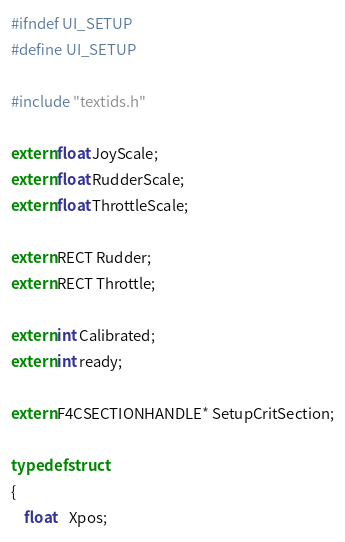Convert code to text. <code><loc_0><loc_0><loc_500><loc_500><_C_>#ifndef UI_SETUP
#define UI_SETUP

#include "textids.h"

extern float JoyScale;
extern float RudderScale;
extern float ThrottleScale;

extern RECT Rudder;
extern RECT Throttle;

extern int Calibrated;
extern int ready;

extern F4CSECTIONHANDLE* SetupCritSection;

typedef struct
{
	float	Xpos;</code> 